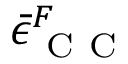Convert formula to latex. <formula><loc_0><loc_0><loc_500><loc_500>\bar { \epsilon } _ { C C } ^ { F }</formula> 